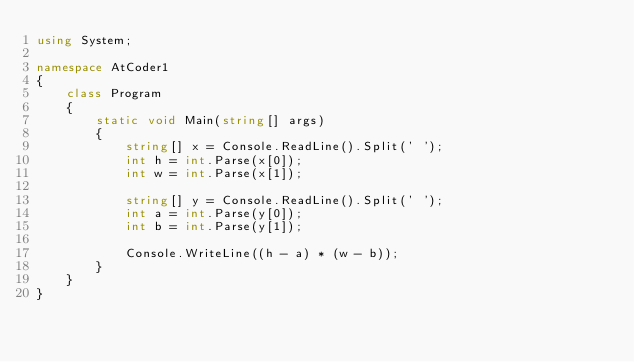<code> <loc_0><loc_0><loc_500><loc_500><_C#_>using System;

namespace AtCoder1
{
    class Program
    {
        static void Main(string[] args)
        {
            string[] x = Console.ReadLine().Split(' ');
            int h = int.Parse(x[0]);
            int w = int.Parse(x[1]);

            string[] y = Console.ReadLine().Split(' ');
            int a = int.Parse(y[0]);
            int b = int.Parse(y[1]);

            Console.WriteLine((h - a) * (w - b));
        }
    }
}
</code> 